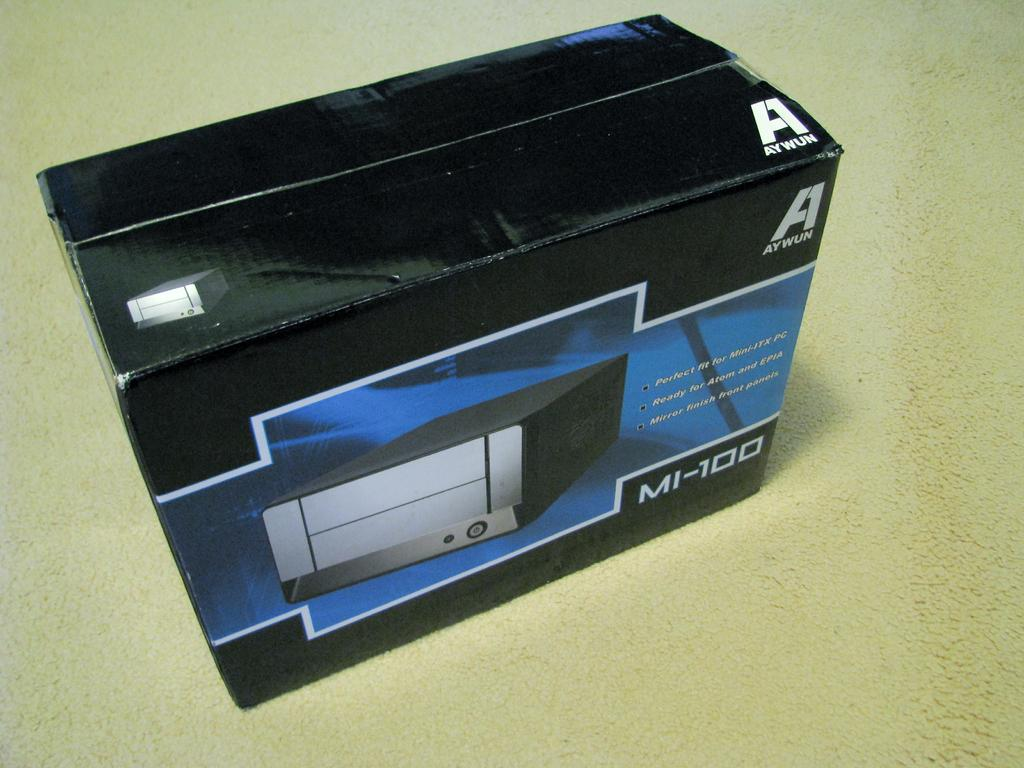<image>
Create a compact narrative representing the image presented. A box has the brand name Aywun, while this item is the MI-100. 